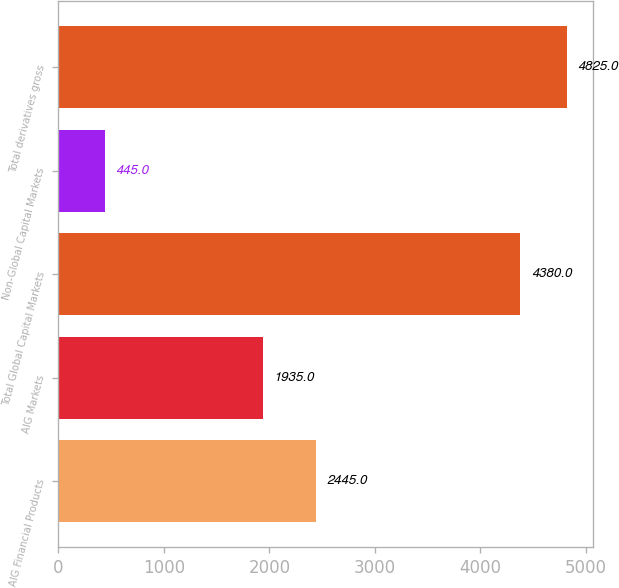Convert chart to OTSL. <chart><loc_0><loc_0><loc_500><loc_500><bar_chart><fcel>AIG Financial Products<fcel>AIG Markets<fcel>Total Global Capital Markets<fcel>Non-Global Capital Markets<fcel>Total derivatives gross<nl><fcel>2445<fcel>1935<fcel>4380<fcel>445<fcel>4825<nl></chart> 